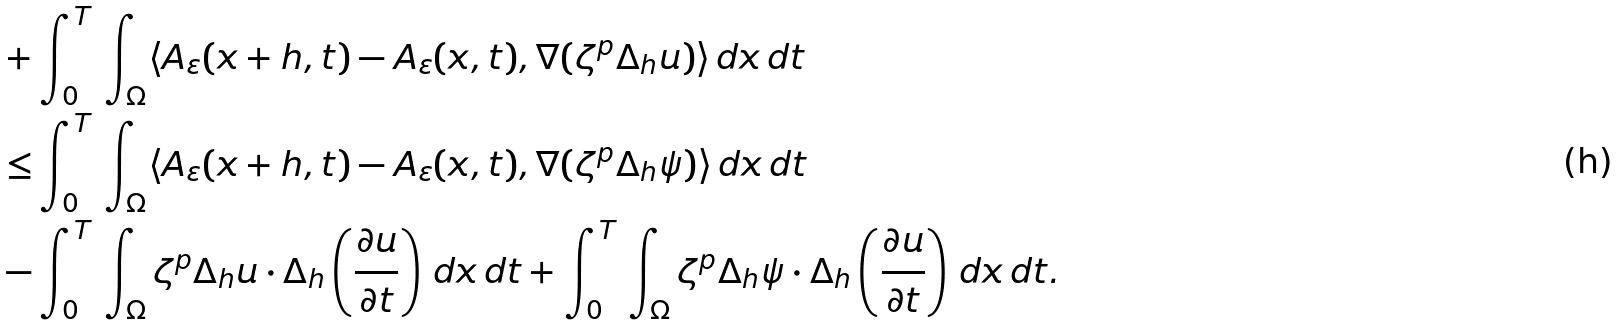<formula> <loc_0><loc_0><loc_500><loc_500>+ & \int _ { 0 } ^ { T } \, \int _ { \Omega } \langle A _ { \varepsilon } ( x + h , t ) - A _ { \varepsilon } ( x , t ) , \nabla ( \zeta ^ { p } \Delta _ { h } u ) \rangle \, d x \, d t \\ \leq & \int _ { 0 } ^ { T } \, \int _ { \Omega } \langle A _ { \varepsilon } ( x + h , t ) - A _ { \varepsilon } ( x , t ) , \nabla ( \zeta ^ { p } \Delta _ { h } \psi ) \rangle \, d x \, d t \\ - & \int _ { 0 } ^ { T } \, \int _ { \Omega } \zeta ^ { p } \Delta _ { h } u \cdot \Delta _ { h } \left ( \frac { \partial u } { \partial t } \right ) \, d x \, d t + \int _ { 0 } ^ { T } \, \int _ { \Omega } \zeta ^ { p } \Delta _ { h } \psi \cdot \Delta _ { h } \left ( \frac { \partial u } { \partial t } \right ) \, d x \, d t .</formula> 